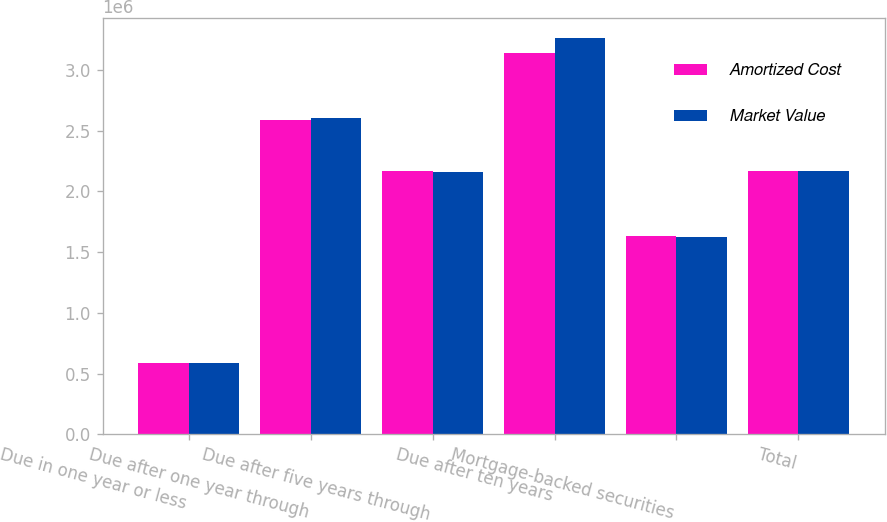Convert chart to OTSL. <chart><loc_0><loc_0><loc_500><loc_500><stacked_bar_chart><ecel><fcel>Due in one year or less<fcel>Due after one year through<fcel>Due after five years through<fcel>Due after ten years<fcel>Mortgage-backed securities<fcel>Total<nl><fcel>Amortized Cost<fcel>585207<fcel>2.58841e+06<fcel>2.16819e+06<fcel>3.13801e+06<fcel>1.63654e+06<fcel>2.16469e+06<nl><fcel>Market Value<fcel>585773<fcel>2.60774e+06<fcel>2.16118e+06<fcel>3.26366e+06<fcel>1.62724e+06<fcel>2.16469e+06<nl></chart> 